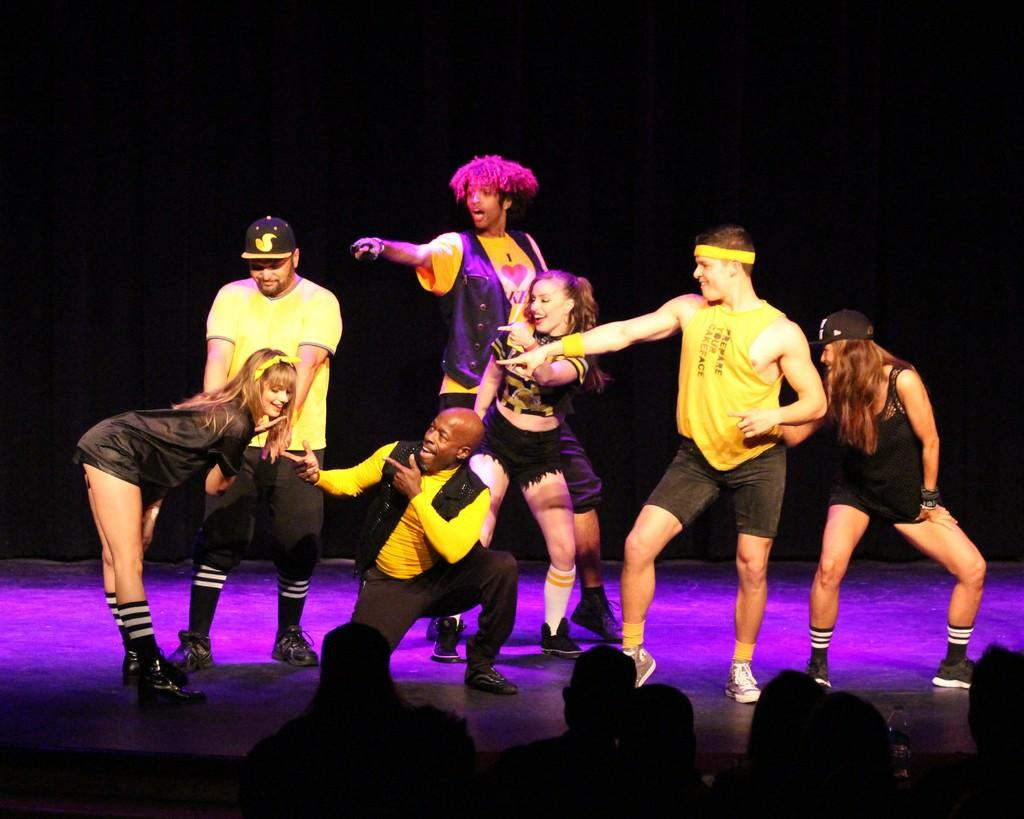What is happening at the bottom of the image? There are people at the bottom of the image. What is happening on the stage in the image? There are people on a stage in the image. How are the people at the bottom of the image interacting with the people on the stage? The people at the bottom are looking at the people on the stage. What type of silver material is being used to care for the people's reactions in the image? There is no silver material or any mention of caring for people's reactions in the image. The image simply shows people at the bottom looking at people on a stage. 